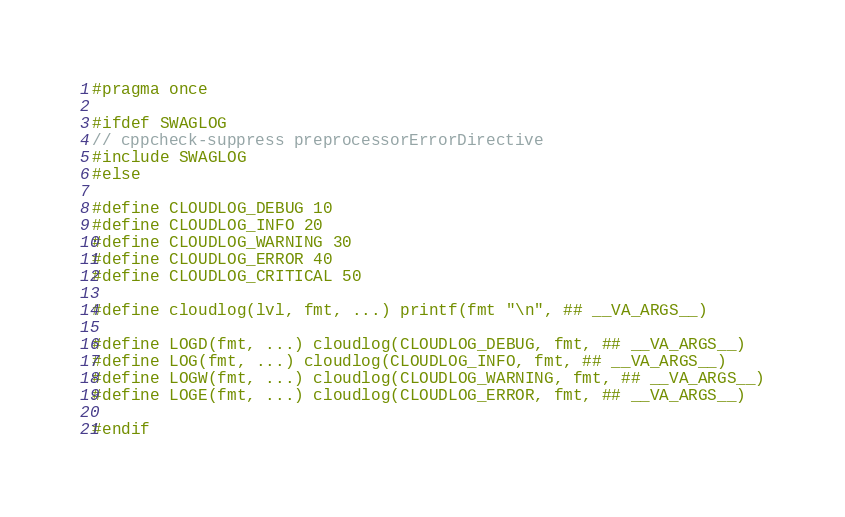<code> <loc_0><loc_0><loc_500><loc_500><_C_>#pragma once

#ifdef SWAGLOG
// cppcheck-suppress preprocessorErrorDirective
#include SWAGLOG
#else

#define CLOUDLOG_DEBUG 10
#define CLOUDLOG_INFO 20
#define CLOUDLOG_WARNING 30
#define CLOUDLOG_ERROR 40
#define CLOUDLOG_CRITICAL 50

#define cloudlog(lvl, fmt, ...) printf(fmt "\n", ## __VA_ARGS__)

#define LOGD(fmt, ...) cloudlog(CLOUDLOG_DEBUG, fmt, ## __VA_ARGS__)
#define LOG(fmt, ...) cloudlog(CLOUDLOG_INFO, fmt, ## __VA_ARGS__)
#define LOGW(fmt, ...) cloudlog(CLOUDLOG_WARNING, fmt, ## __VA_ARGS__)
#define LOGE(fmt, ...) cloudlog(CLOUDLOG_ERROR, fmt, ## __VA_ARGS__)

#endif
</code> 